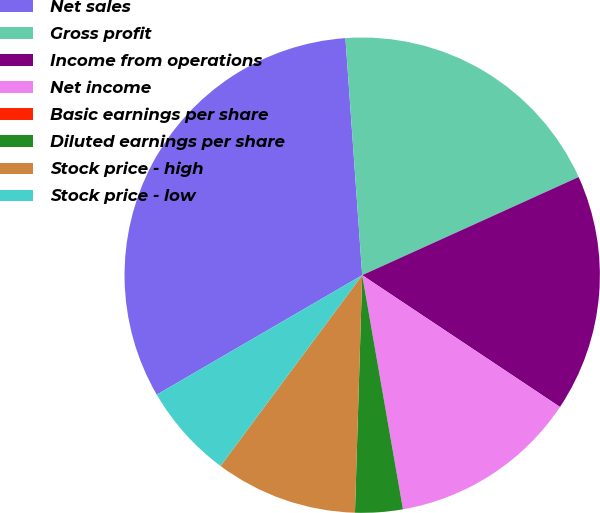<chart> <loc_0><loc_0><loc_500><loc_500><pie_chart><fcel>Net sales<fcel>Gross profit<fcel>Income from operations<fcel>Net income<fcel>Basic earnings per share<fcel>Diluted earnings per share<fcel>Stock price - high<fcel>Stock price - low<nl><fcel>32.26%<fcel>19.35%<fcel>16.13%<fcel>12.9%<fcel>0.0%<fcel>3.23%<fcel>9.68%<fcel>6.45%<nl></chart> 